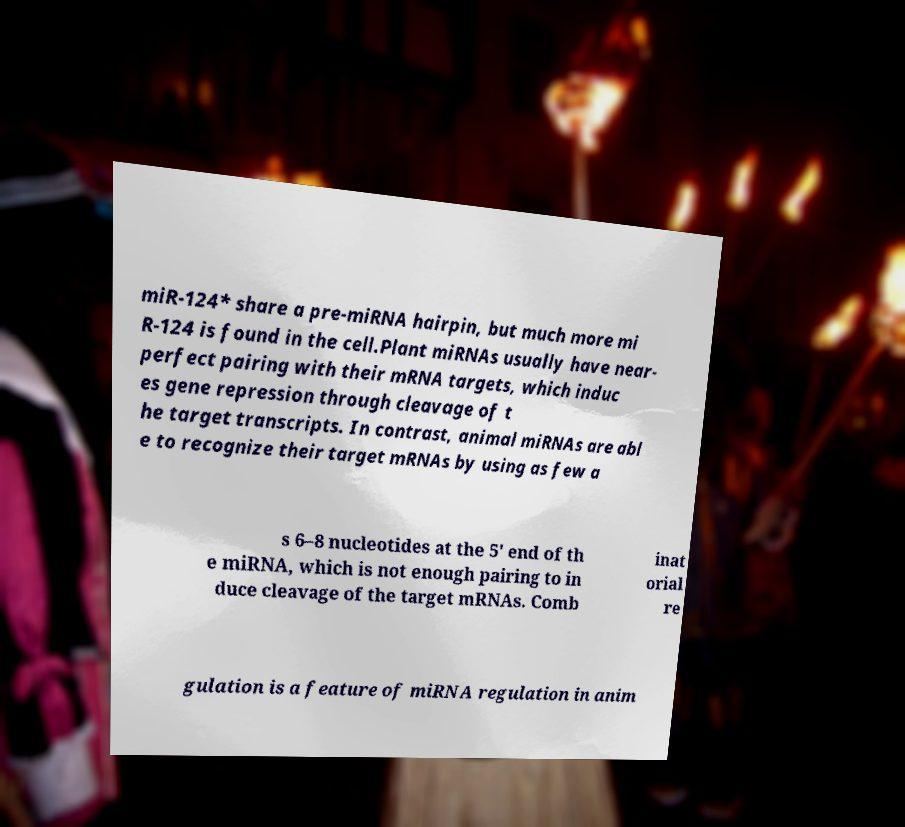Please identify and transcribe the text found in this image. miR-124* share a pre-miRNA hairpin, but much more mi R-124 is found in the cell.Plant miRNAs usually have near- perfect pairing with their mRNA targets, which induc es gene repression through cleavage of t he target transcripts. In contrast, animal miRNAs are abl e to recognize their target mRNAs by using as few a s 6–8 nucleotides at the 5' end of th e miRNA, which is not enough pairing to in duce cleavage of the target mRNAs. Comb inat orial re gulation is a feature of miRNA regulation in anim 